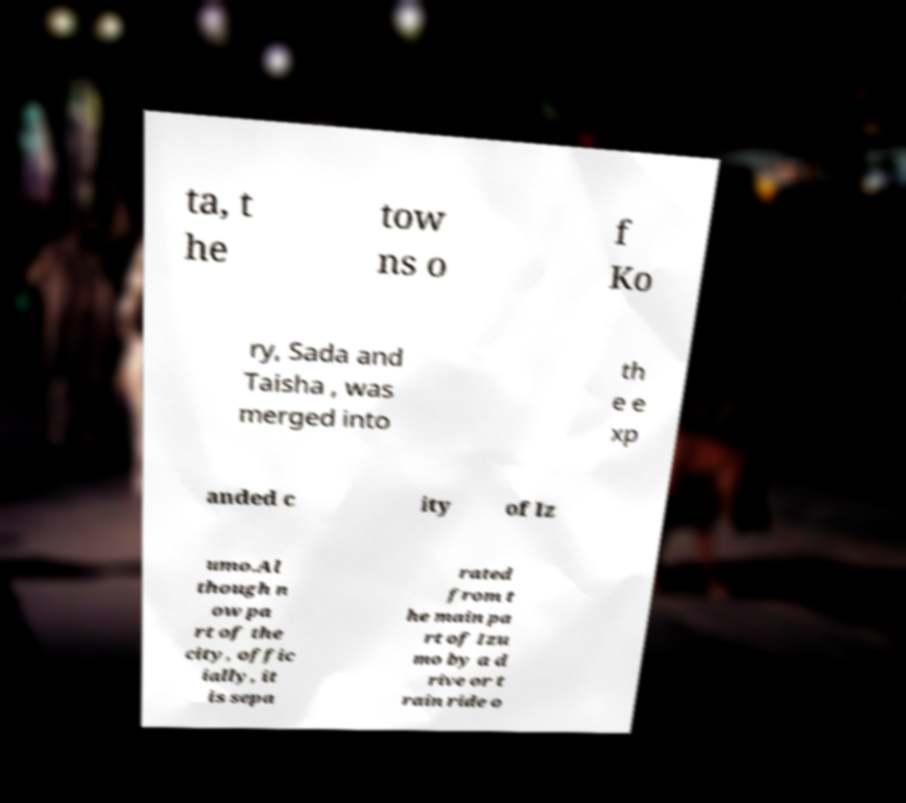Please read and relay the text visible in this image. What does it say? ta, t he tow ns o f Ko ry, Sada and Taisha , was merged into th e e xp anded c ity of Iz umo.Al though n ow pa rt of the city, offic ially, it is sepa rated from t he main pa rt of Izu mo by a d rive or t rain ride o 